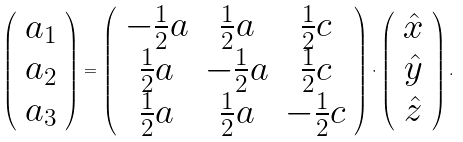Convert formula to latex. <formula><loc_0><loc_0><loc_500><loc_500>\left ( \begin{array} { c } { a } _ { 1 } \\ { a } _ { 2 } \\ { a } _ { 3 } \end{array} \right ) = \left ( \begin{array} { c c c } - \frac { 1 } { 2 } a & \frac { 1 } { 2 } a & \frac { 1 } { 2 } c \\ \frac { 1 } { 2 } a & - \frac { 1 } { 2 } a & \frac { 1 } { 2 } c \\ \frac { 1 } { 2 } a & \frac { 1 } { 2 } a & - \frac { 1 } { 2 } c \\ \end{array} \right ) \cdot \left ( \begin{array} { c } \hat { x } \\ \hat { y } \\ \hat { z } \end{array} \right ) .</formula> 